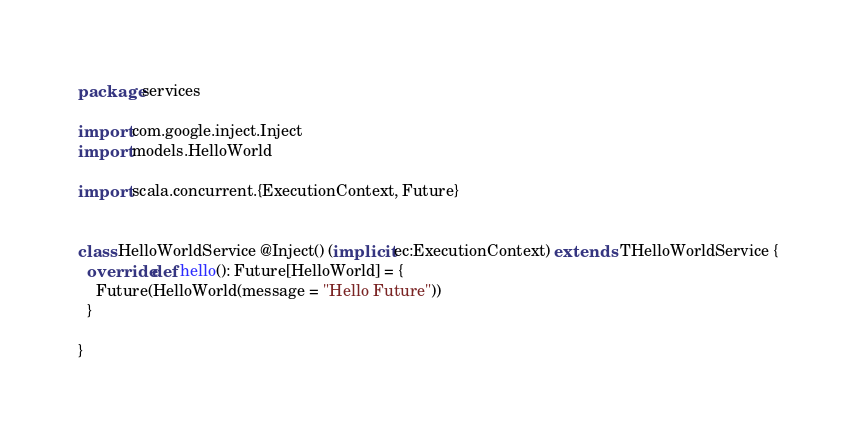Convert code to text. <code><loc_0><loc_0><loc_500><loc_500><_Scala_>package services

import com.google.inject.Inject
import models.HelloWorld

import scala.concurrent.{ExecutionContext, Future}


class HelloWorldService @Inject() (implicit ec:ExecutionContext) extends  THelloWorldService {
  override def hello(): Future[HelloWorld] = {
    Future(HelloWorld(message = "Hello Future"))
  }

}
</code> 